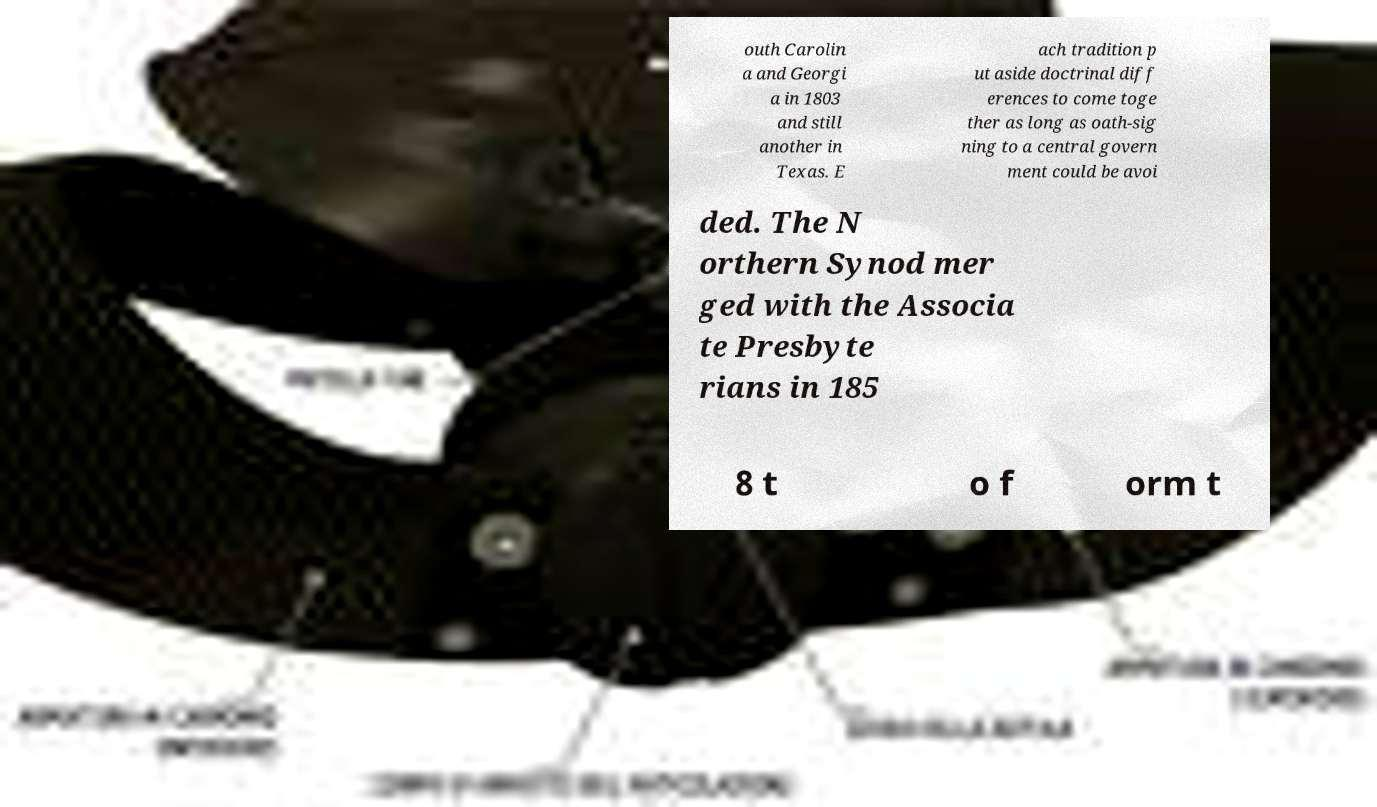Can you accurately transcribe the text from the provided image for me? outh Carolin a and Georgi a in 1803 and still another in Texas. E ach tradition p ut aside doctrinal diff erences to come toge ther as long as oath-sig ning to a central govern ment could be avoi ded. The N orthern Synod mer ged with the Associa te Presbyte rians in 185 8 t o f orm t 